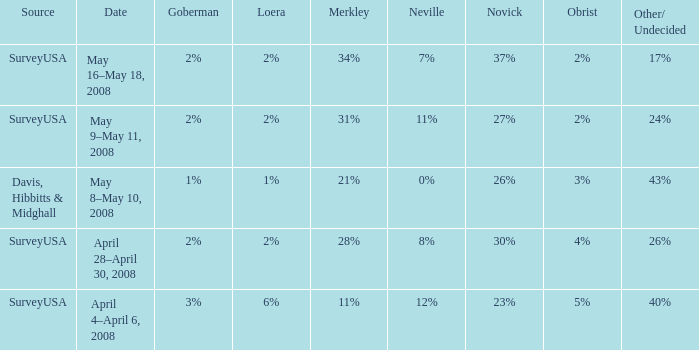Which goberman possesses an obrist of 2%, and a merkley of 34%? 2%. 